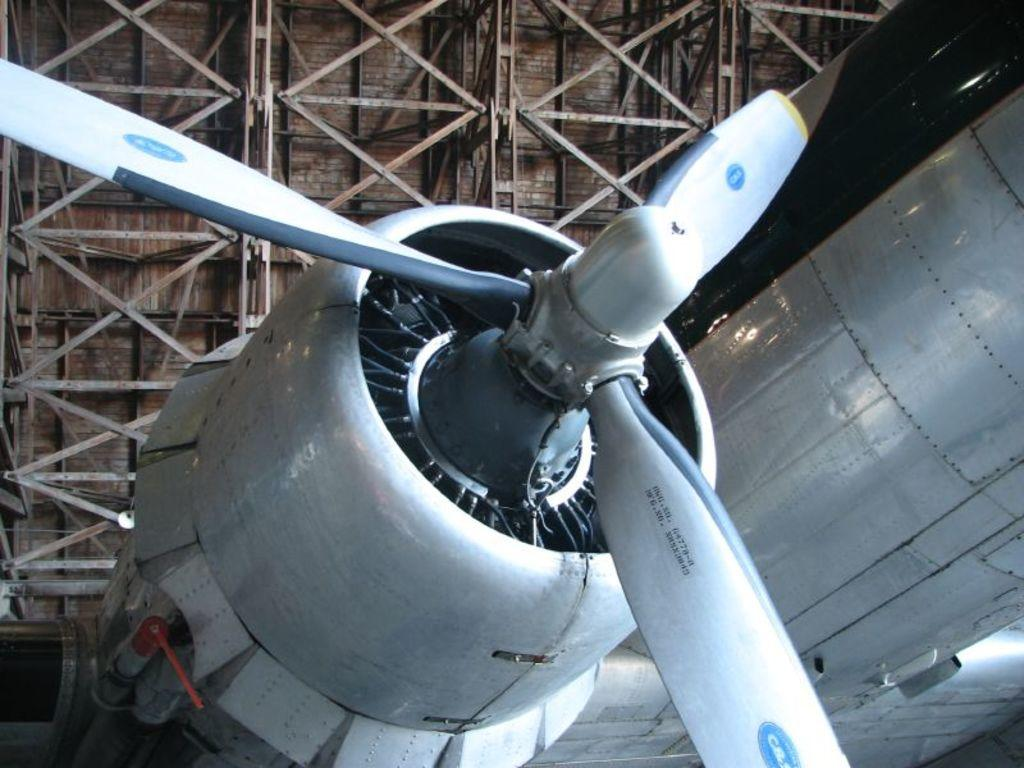What is the main subject of the image? The main subject of the image is a part of an aircraft engine. What specific feature can be seen on the aircraft engine? The aircraft engine has a fan. What is visible above the aircraft engine in the image? There is a ceiling visible in the image. What type of structural support is attached to the ceiling? Iron rods are attached to the ceiling. How many ants can be seen crawling on the aircraft engine in the image? There are no ants present on the aircraft engine in the image. What type of stocking is the visitor wearing in the image? There is no visitor present in the image, so it is not possible to determine what type of stocking they might be wearing. 